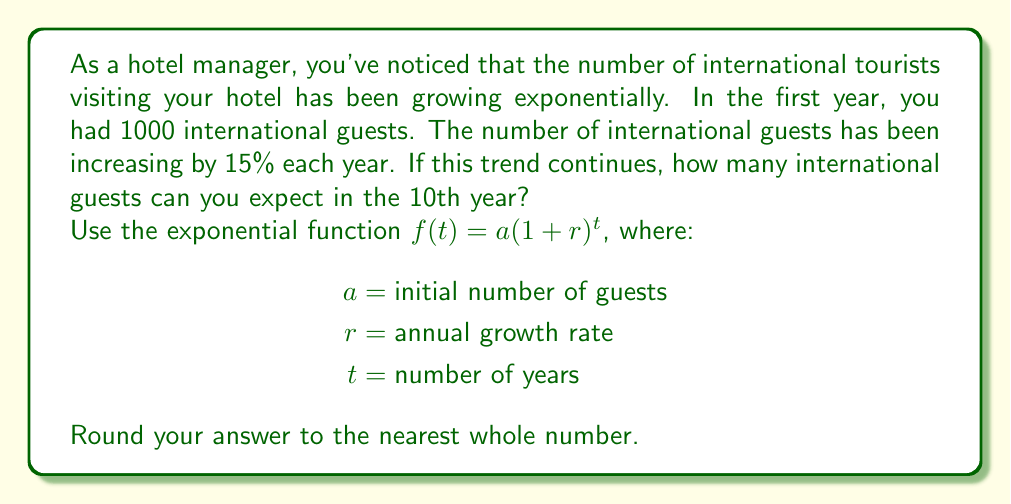What is the answer to this math problem? To solve this problem, we'll use the exponential growth function:

$$f(t) = a(1+r)^t$$

Where:
$a = 1000$ (initial number of guests)
$r = 0.15$ (15% annual growth rate)
$t = 10$ (we want to know the number of guests in the 10th year)

Let's substitute these values into the equation:

$$f(10) = 1000(1+0.15)^{10}$$

Now, let's calculate step-by-step:

1) First, calculate $(1+0.15)^{10}$:
   $$(1.15)^{10} \approx 4.0456$$

2) Now multiply this by the initial number of guests:
   $$1000 \times 4.0456 = 4045.6$$

3) Round to the nearest whole number:
   $$4045.6 \approx 4046$$

Therefore, if the exponential growth trend continues, you can expect approximately 4046 international guests in the 10th year.
Answer: 4046 international guests 